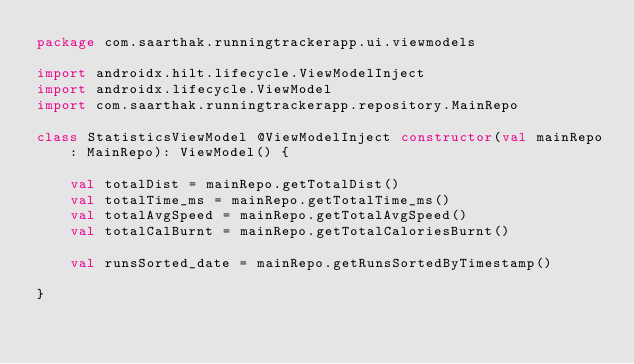<code> <loc_0><loc_0><loc_500><loc_500><_Kotlin_>package com.saarthak.runningtrackerapp.ui.viewmodels

import androidx.hilt.lifecycle.ViewModelInject
import androidx.lifecycle.ViewModel
import com.saarthak.runningtrackerapp.repository.MainRepo

class StatisticsViewModel @ViewModelInject constructor(val mainRepo: MainRepo): ViewModel() {

    val totalDist = mainRepo.getTotalDist()
    val totalTime_ms = mainRepo.getTotalTime_ms()
    val totalAvgSpeed = mainRepo.getTotalAvgSpeed()
    val totalCalBurnt = mainRepo.getTotalCaloriesBurnt()

    val runsSorted_date = mainRepo.getRunsSortedByTimestamp()

}</code> 